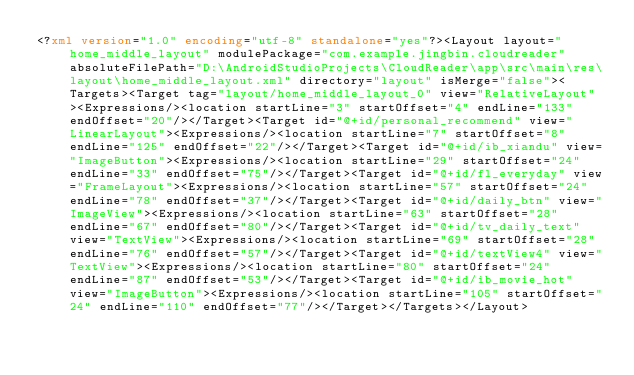Convert code to text. <code><loc_0><loc_0><loc_500><loc_500><_XML_><?xml version="1.0" encoding="utf-8" standalone="yes"?><Layout layout="home_middle_layout" modulePackage="com.example.jingbin.cloudreader" absoluteFilePath="D:\AndroidStudioProjects\CloudReader\app\src\main\res\layout\home_middle_layout.xml" directory="layout" isMerge="false"><Targets><Target tag="layout/home_middle_layout_0" view="RelativeLayout"><Expressions/><location startLine="3" startOffset="4" endLine="133" endOffset="20"/></Target><Target id="@+id/personal_recommend" view="LinearLayout"><Expressions/><location startLine="7" startOffset="8" endLine="125" endOffset="22"/></Target><Target id="@+id/ib_xiandu" view="ImageButton"><Expressions/><location startLine="29" startOffset="24" endLine="33" endOffset="75"/></Target><Target id="@+id/fl_everyday" view="FrameLayout"><Expressions/><location startLine="57" startOffset="24" endLine="78" endOffset="37"/></Target><Target id="@+id/daily_btn" view="ImageView"><Expressions/><location startLine="63" startOffset="28" endLine="67" endOffset="80"/></Target><Target id="@+id/tv_daily_text" view="TextView"><Expressions/><location startLine="69" startOffset="28" endLine="76" endOffset="57"/></Target><Target id="@+id/textView4" view="TextView"><Expressions/><location startLine="80" startOffset="24" endLine="87" endOffset="53"/></Target><Target id="@+id/ib_movie_hot" view="ImageButton"><Expressions/><location startLine="105" startOffset="24" endLine="110" endOffset="77"/></Target></Targets></Layout></code> 